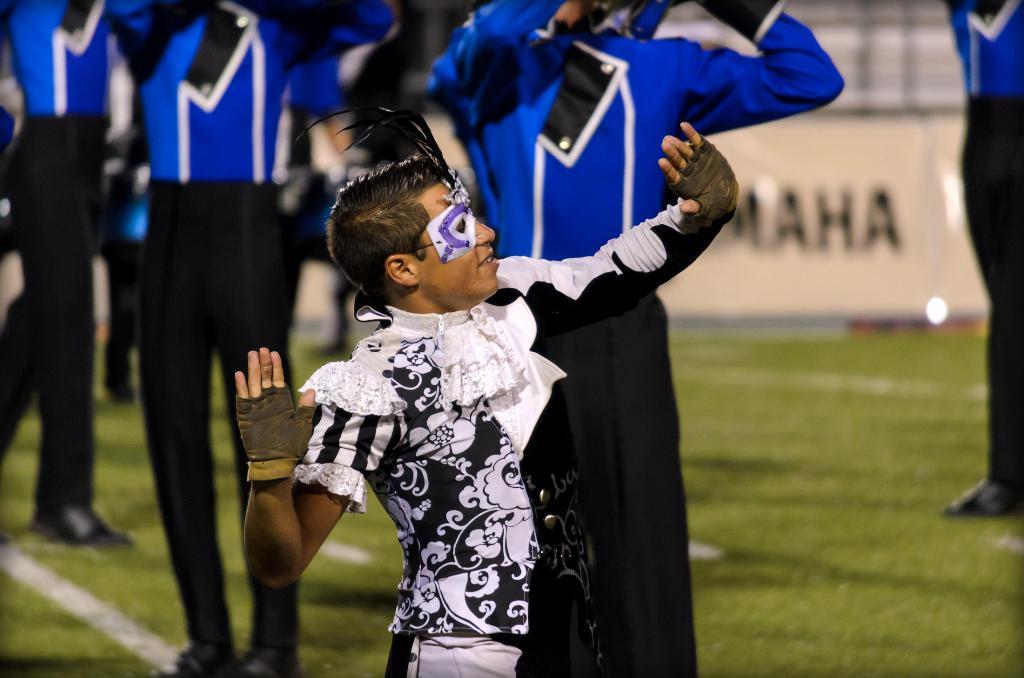What s the full word being advertised in the back?
Provide a short and direct response. Yamaha. 